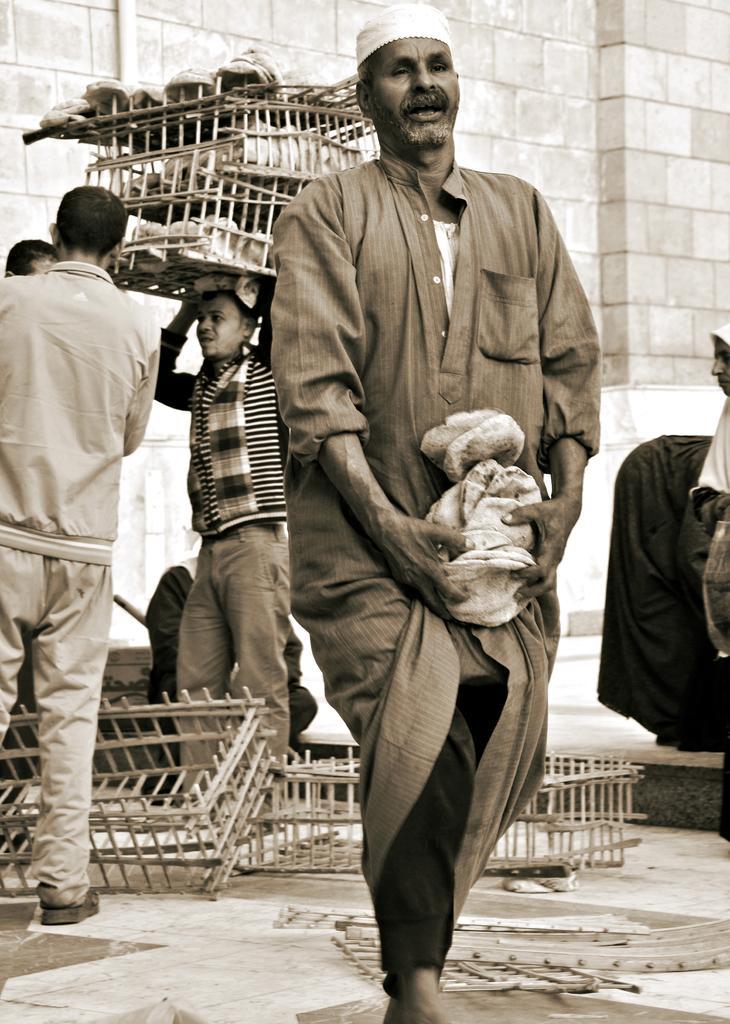Could you give a brief overview of what you see in this image? In this image I can see few people wearing the dresses and I can see one person carrying the baskets. In the background I can see the wall. 